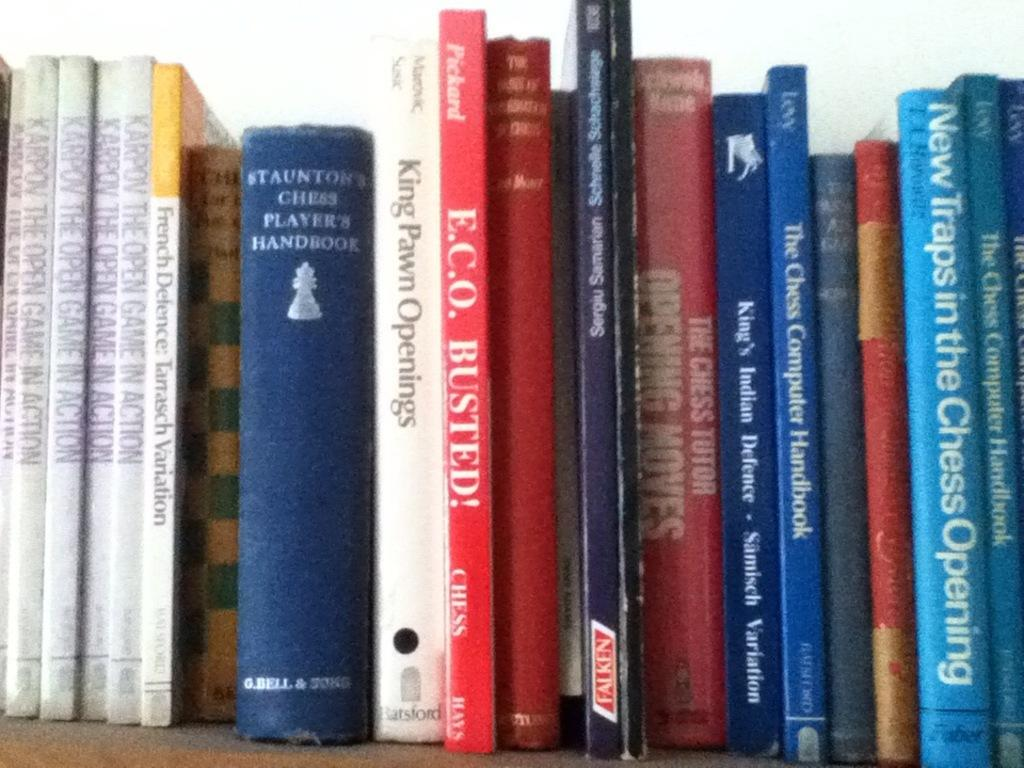<image>
Provide a brief description of the given image. A shelf full of books including ECO Busted! 